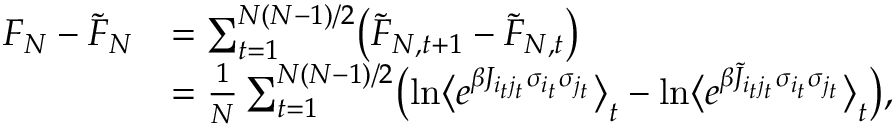<formula> <loc_0><loc_0><loc_500><loc_500>\begin{array} { r l } { F _ { N } - \tilde { F } _ { N } } & { = \sum _ { t = 1 } ^ { N ( N - 1 ) / 2 } \left ( \tilde { F } _ { N , t + 1 } - \tilde { F } _ { N , t } \right ) } \\ & { = \frac { 1 } { N } \sum _ { t = 1 } ^ { N ( N - 1 ) / 2 } \left ( \ln \left \langle e ^ { \beta J _ { i _ { t } j _ { t } } \sigma _ { i _ { t } } \sigma _ { j _ { t } } } \right \rangle _ { t } - \ln \left \langle e ^ { \beta \tilde { J } _ { i _ { t } j _ { t } } \sigma _ { i _ { t } } \sigma _ { j _ { t } } } \right \rangle _ { t } \right ) , } \end{array}</formula> 